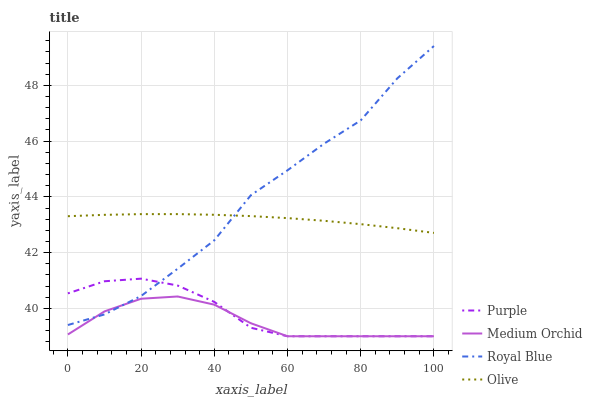Does Medium Orchid have the minimum area under the curve?
Answer yes or no. Yes. Does Royal Blue have the maximum area under the curve?
Answer yes or no. Yes. Does Royal Blue have the minimum area under the curve?
Answer yes or no. No. Does Medium Orchid have the maximum area under the curve?
Answer yes or no. No. Is Olive the smoothest?
Answer yes or no. Yes. Is Royal Blue the roughest?
Answer yes or no. Yes. Is Medium Orchid the smoothest?
Answer yes or no. No. Is Medium Orchid the roughest?
Answer yes or no. No. Does Purple have the lowest value?
Answer yes or no. Yes. Does Royal Blue have the lowest value?
Answer yes or no. No. Does Royal Blue have the highest value?
Answer yes or no. Yes. Does Medium Orchid have the highest value?
Answer yes or no. No. Is Medium Orchid less than Olive?
Answer yes or no. Yes. Is Olive greater than Purple?
Answer yes or no. Yes. Does Medium Orchid intersect Purple?
Answer yes or no. Yes. Is Medium Orchid less than Purple?
Answer yes or no. No. Is Medium Orchid greater than Purple?
Answer yes or no. No. Does Medium Orchid intersect Olive?
Answer yes or no. No. 